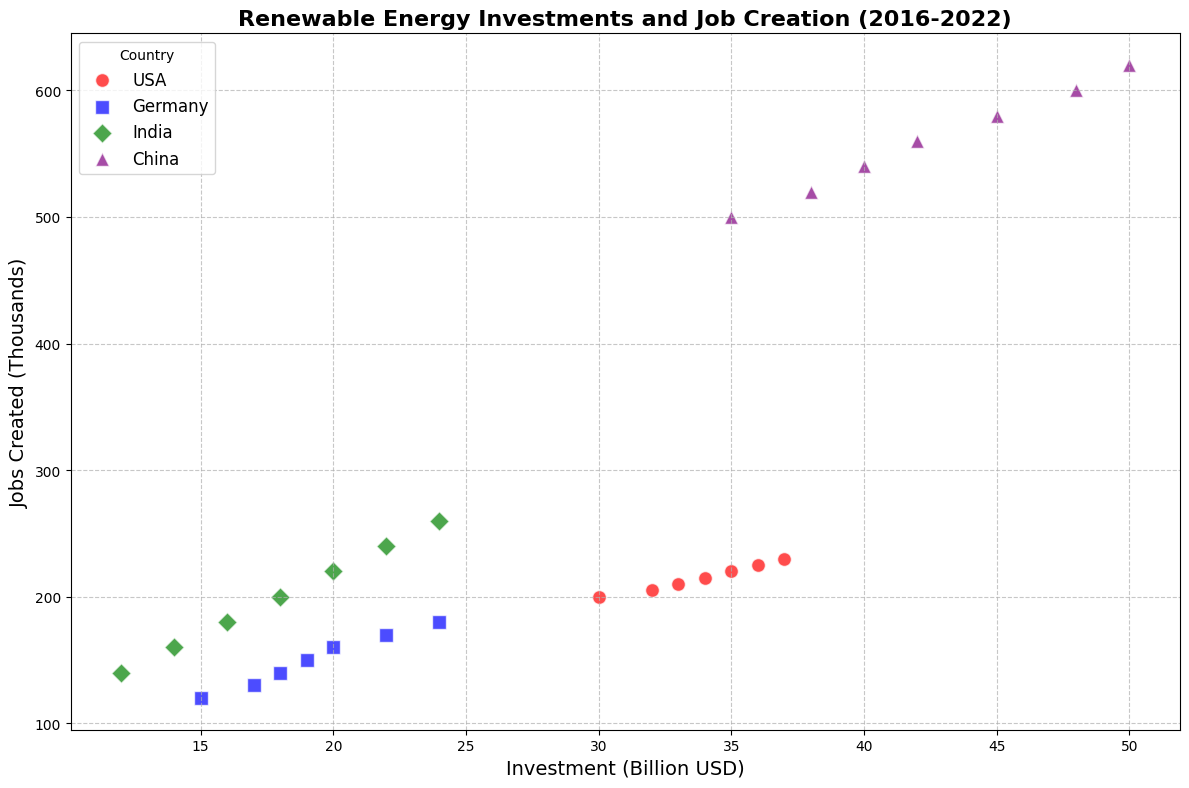Which country shows the highest investment in renewable energy in 2022? The scatter plot uses different colors to represent each country. By looking at the axis labeled 'Investment (Billion USD)' and finding the highest value for the year 2022, we see that China has the highest investment depicted in purple.
Answer: China Which country created more jobs with a higher investment in 2020, USA or India? The scatter plot shows different markers for countries. In 2020, USA (red circles) had an investment of 35 billion USD creating 220 thousand jobs, while India (green diamonds) had an investment of 20 billion USD creating 220 thousand jobs, showing USA had a higher investment but both created the same number of jobs.
Answer: USA How does Germany's investment trend over the years compare to India's in terms of stability of growth? By observing the scatter plot, we see that Germany (blue squares) shows a steady and gradual increase in investment each year from 15 to 24 billion USD. India (green diamonds), however, has more variability with steps in 2 billion USD increments indicating lesser stability compared to Germany.
Answer: Germany has more stable growth Comparing the jobs created in 2016 and 2022 by all countries, which country shows the greatest difference? Checking the scatter plot, for 2016 and 2022, we calculate the differences in jobs created for each country: USA (230-200=30), Germany (180-120=60), India (260-140=120), and China (620-500=120). Both India and China show the greatest difference (120 thousand).
Answer: India and China What is the average investment in renewable energy for Germany from 2016 to 2022? Summing up Germany's investments (15 + 17 + 18 + 19 + 20 + 22 + 24 billion USD) gives a total of 135 billion USD. Dividing this by the 7 years, we get an average. 135/7 = 19.3 billion USD.
Answer: 19.3 billion USD Compare the job creation efficiency (jobs created per billion USD) of China and India in 2021? For China in 2021: Jobs created (600) divided by Investment (48) = 12.5 jobs per billion USD. For India in 2021: Jobs created (240) divided by Investment (22) = 10.9 jobs per billion USD. China demonstrated higher job creation efficiency.
Answer: China Which year's data point for the USA is farthest from the others in terms of jobs created and investment? Inspecting the cluster of red circles representing the USA, the data points from each year are quite close, but 2022 seems to be slightly farther from the cluster with an investment of 37 billion USD and jobs created of 230 thousand.
Answer: 2022 In 2019, which country had the lowest job creation for its investment, and what was that investment? By comparing each country's data in 2019, we see that Germany had the lowest job creation (150 thousand) shown as blue squares. This corresponds to an investment of 19 billion USD.
Answer: Germany, 19 billion USD 